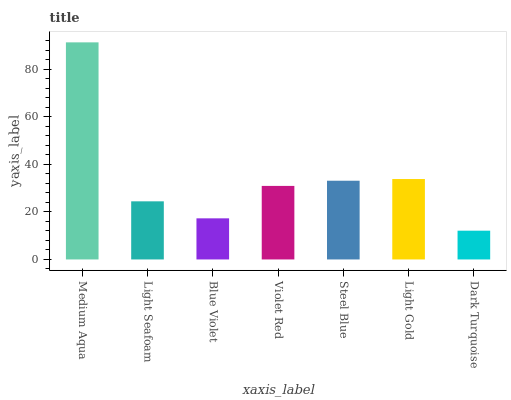Is Dark Turquoise the minimum?
Answer yes or no. Yes. Is Medium Aqua the maximum?
Answer yes or no. Yes. Is Light Seafoam the minimum?
Answer yes or no. No. Is Light Seafoam the maximum?
Answer yes or no. No. Is Medium Aqua greater than Light Seafoam?
Answer yes or no. Yes. Is Light Seafoam less than Medium Aqua?
Answer yes or no. Yes. Is Light Seafoam greater than Medium Aqua?
Answer yes or no. No. Is Medium Aqua less than Light Seafoam?
Answer yes or no. No. Is Violet Red the high median?
Answer yes or no. Yes. Is Violet Red the low median?
Answer yes or no. Yes. Is Dark Turquoise the high median?
Answer yes or no. No. Is Blue Violet the low median?
Answer yes or no. No. 